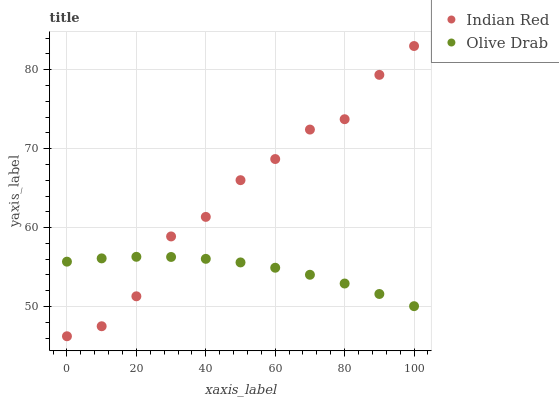Does Olive Drab have the minimum area under the curve?
Answer yes or no. Yes. Does Indian Red have the maximum area under the curve?
Answer yes or no. Yes. Does Indian Red have the minimum area under the curve?
Answer yes or no. No. Is Olive Drab the smoothest?
Answer yes or no. Yes. Is Indian Red the roughest?
Answer yes or no. Yes. Is Indian Red the smoothest?
Answer yes or no. No. Does Indian Red have the lowest value?
Answer yes or no. Yes. Does Indian Red have the highest value?
Answer yes or no. Yes. Does Indian Red intersect Olive Drab?
Answer yes or no. Yes. Is Indian Red less than Olive Drab?
Answer yes or no. No. Is Indian Red greater than Olive Drab?
Answer yes or no. No. 